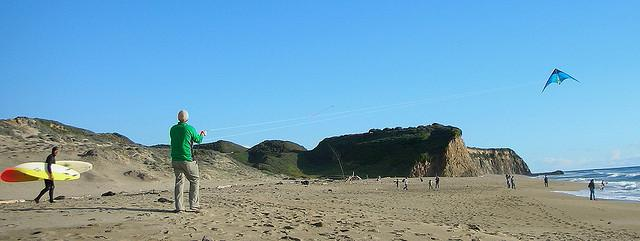What is the man carrying to the water?

Choices:
A) buckets
B) blankets
C) chairs
D) surfboards surfboards 